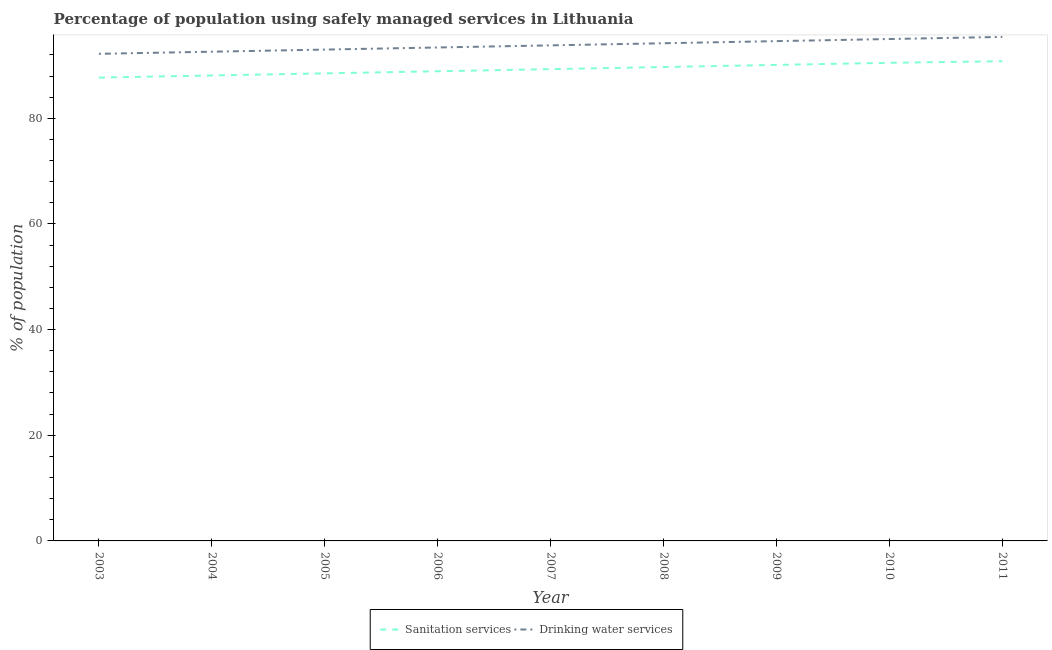What is the percentage of population who used drinking water services in 2003?
Your answer should be very brief. 92.2. Across all years, what is the maximum percentage of population who used drinking water services?
Provide a succinct answer. 95.4. Across all years, what is the minimum percentage of population who used drinking water services?
Ensure brevity in your answer.  92.2. In which year was the percentage of population who used sanitation services minimum?
Offer a terse response. 2003. What is the total percentage of population who used drinking water services in the graph?
Make the answer very short. 844.2. What is the difference between the percentage of population who used drinking water services in 2006 and that in 2009?
Offer a very short reply. -1.2. What is the difference between the percentage of population who used drinking water services in 2004 and the percentage of population who used sanitation services in 2006?
Provide a short and direct response. 3.7. What is the average percentage of population who used drinking water services per year?
Give a very brief answer. 93.8. In the year 2005, what is the difference between the percentage of population who used drinking water services and percentage of population who used sanitation services?
Your response must be concise. 4.5. In how many years, is the percentage of population who used drinking water services greater than 64 %?
Provide a succinct answer. 9. What is the ratio of the percentage of population who used drinking water services in 2005 to that in 2006?
Your response must be concise. 1. What is the difference between the highest and the second highest percentage of population who used drinking water services?
Make the answer very short. 0.4. What is the difference between the highest and the lowest percentage of population who used sanitation services?
Provide a succinct answer. 3.1. Does the percentage of population who used drinking water services monotonically increase over the years?
Offer a terse response. Yes. Is the percentage of population who used drinking water services strictly greater than the percentage of population who used sanitation services over the years?
Keep it short and to the point. Yes. How many lines are there?
Provide a succinct answer. 2. How many years are there in the graph?
Make the answer very short. 9. What is the difference between two consecutive major ticks on the Y-axis?
Your response must be concise. 20. Are the values on the major ticks of Y-axis written in scientific E-notation?
Your response must be concise. No. Does the graph contain grids?
Offer a very short reply. No. What is the title of the graph?
Your answer should be very brief. Percentage of population using safely managed services in Lithuania. Does "constant 2005 US$" appear as one of the legend labels in the graph?
Keep it short and to the point. No. What is the label or title of the Y-axis?
Make the answer very short. % of population. What is the % of population of Sanitation services in 2003?
Keep it short and to the point. 87.7. What is the % of population in Drinking water services in 2003?
Ensure brevity in your answer.  92.2. What is the % of population of Sanitation services in 2004?
Provide a short and direct response. 88.1. What is the % of population in Drinking water services in 2004?
Offer a very short reply. 92.6. What is the % of population in Sanitation services in 2005?
Your response must be concise. 88.5. What is the % of population of Drinking water services in 2005?
Your answer should be compact. 93. What is the % of population of Sanitation services in 2006?
Your response must be concise. 88.9. What is the % of population in Drinking water services in 2006?
Make the answer very short. 93.4. What is the % of population in Sanitation services in 2007?
Keep it short and to the point. 89.3. What is the % of population in Drinking water services in 2007?
Keep it short and to the point. 93.8. What is the % of population in Sanitation services in 2008?
Keep it short and to the point. 89.7. What is the % of population of Drinking water services in 2008?
Make the answer very short. 94.2. What is the % of population of Sanitation services in 2009?
Ensure brevity in your answer.  90.1. What is the % of population of Drinking water services in 2009?
Keep it short and to the point. 94.6. What is the % of population in Sanitation services in 2010?
Offer a very short reply. 90.5. What is the % of population of Drinking water services in 2010?
Offer a terse response. 95. What is the % of population in Sanitation services in 2011?
Give a very brief answer. 90.8. What is the % of population in Drinking water services in 2011?
Your answer should be compact. 95.4. Across all years, what is the maximum % of population of Sanitation services?
Your response must be concise. 90.8. Across all years, what is the maximum % of population in Drinking water services?
Make the answer very short. 95.4. Across all years, what is the minimum % of population in Sanitation services?
Give a very brief answer. 87.7. Across all years, what is the minimum % of population of Drinking water services?
Give a very brief answer. 92.2. What is the total % of population of Sanitation services in the graph?
Ensure brevity in your answer.  803.6. What is the total % of population of Drinking water services in the graph?
Your answer should be very brief. 844.2. What is the difference between the % of population of Drinking water services in 2003 and that in 2004?
Provide a succinct answer. -0.4. What is the difference between the % of population in Sanitation services in 2003 and that in 2005?
Ensure brevity in your answer.  -0.8. What is the difference between the % of population of Sanitation services in 2003 and that in 2006?
Make the answer very short. -1.2. What is the difference between the % of population of Sanitation services in 2003 and that in 2007?
Keep it short and to the point. -1.6. What is the difference between the % of population in Drinking water services in 2003 and that in 2007?
Your answer should be very brief. -1.6. What is the difference between the % of population in Drinking water services in 2003 and that in 2008?
Give a very brief answer. -2. What is the difference between the % of population of Sanitation services in 2003 and that in 2009?
Give a very brief answer. -2.4. What is the difference between the % of population of Drinking water services in 2003 and that in 2010?
Keep it short and to the point. -2.8. What is the difference between the % of population of Sanitation services in 2003 and that in 2011?
Your answer should be very brief. -3.1. What is the difference between the % of population of Sanitation services in 2004 and that in 2005?
Offer a very short reply. -0.4. What is the difference between the % of population of Sanitation services in 2004 and that in 2006?
Your answer should be very brief. -0.8. What is the difference between the % of population in Sanitation services in 2004 and that in 2007?
Offer a terse response. -1.2. What is the difference between the % of population of Drinking water services in 2004 and that in 2008?
Offer a terse response. -1.6. What is the difference between the % of population in Sanitation services in 2004 and that in 2009?
Offer a terse response. -2. What is the difference between the % of population in Sanitation services in 2004 and that in 2010?
Provide a short and direct response. -2.4. What is the difference between the % of population in Sanitation services in 2005 and that in 2006?
Make the answer very short. -0.4. What is the difference between the % of population in Drinking water services in 2005 and that in 2006?
Your response must be concise. -0.4. What is the difference between the % of population of Sanitation services in 2005 and that in 2007?
Give a very brief answer. -0.8. What is the difference between the % of population of Drinking water services in 2005 and that in 2008?
Give a very brief answer. -1.2. What is the difference between the % of population in Drinking water services in 2005 and that in 2011?
Ensure brevity in your answer.  -2.4. What is the difference between the % of population of Sanitation services in 2006 and that in 2007?
Your response must be concise. -0.4. What is the difference between the % of population of Sanitation services in 2006 and that in 2008?
Provide a succinct answer. -0.8. What is the difference between the % of population in Drinking water services in 2006 and that in 2008?
Your response must be concise. -0.8. What is the difference between the % of population of Drinking water services in 2006 and that in 2009?
Ensure brevity in your answer.  -1.2. What is the difference between the % of population in Sanitation services in 2006 and that in 2011?
Your answer should be very brief. -1.9. What is the difference between the % of population in Drinking water services in 2006 and that in 2011?
Make the answer very short. -2. What is the difference between the % of population in Sanitation services in 2007 and that in 2009?
Offer a very short reply. -0.8. What is the difference between the % of population of Sanitation services in 2008 and that in 2009?
Keep it short and to the point. -0.4. What is the difference between the % of population of Sanitation services in 2008 and that in 2011?
Your answer should be compact. -1.1. What is the difference between the % of population in Sanitation services in 2009 and that in 2010?
Offer a terse response. -0.4. What is the difference between the % of population of Sanitation services in 2009 and that in 2011?
Offer a terse response. -0.7. What is the difference between the % of population in Sanitation services in 2003 and the % of population in Drinking water services in 2011?
Offer a very short reply. -7.7. What is the difference between the % of population of Sanitation services in 2004 and the % of population of Drinking water services in 2009?
Your answer should be very brief. -6.5. What is the difference between the % of population in Sanitation services in 2005 and the % of population in Drinking water services in 2010?
Provide a succinct answer. -6.5. What is the difference between the % of population of Sanitation services in 2005 and the % of population of Drinking water services in 2011?
Give a very brief answer. -6.9. What is the difference between the % of population of Sanitation services in 2007 and the % of population of Drinking water services in 2008?
Ensure brevity in your answer.  -4.9. What is the difference between the % of population of Sanitation services in 2007 and the % of population of Drinking water services in 2010?
Offer a very short reply. -5.7. What is the difference between the % of population in Sanitation services in 2007 and the % of population in Drinking water services in 2011?
Ensure brevity in your answer.  -6.1. What is the difference between the % of population in Sanitation services in 2008 and the % of population in Drinking water services in 2009?
Offer a terse response. -4.9. What is the difference between the % of population in Sanitation services in 2008 and the % of population in Drinking water services in 2011?
Provide a succinct answer. -5.7. What is the difference between the % of population in Sanitation services in 2009 and the % of population in Drinking water services in 2010?
Your answer should be compact. -4.9. What is the difference between the % of population of Sanitation services in 2010 and the % of population of Drinking water services in 2011?
Offer a very short reply. -4.9. What is the average % of population in Sanitation services per year?
Give a very brief answer. 89.29. What is the average % of population of Drinking water services per year?
Ensure brevity in your answer.  93.8. In the year 2003, what is the difference between the % of population of Sanitation services and % of population of Drinking water services?
Offer a very short reply. -4.5. In the year 2004, what is the difference between the % of population in Sanitation services and % of population in Drinking water services?
Make the answer very short. -4.5. In the year 2006, what is the difference between the % of population of Sanitation services and % of population of Drinking water services?
Your answer should be very brief. -4.5. In the year 2011, what is the difference between the % of population of Sanitation services and % of population of Drinking water services?
Offer a terse response. -4.6. What is the ratio of the % of population of Drinking water services in 2003 to that in 2005?
Ensure brevity in your answer.  0.99. What is the ratio of the % of population of Sanitation services in 2003 to that in 2006?
Your answer should be compact. 0.99. What is the ratio of the % of population of Drinking water services in 2003 to that in 2006?
Offer a terse response. 0.99. What is the ratio of the % of population in Sanitation services in 2003 to that in 2007?
Offer a very short reply. 0.98. What is the ratio of the % of population of Drinking water services in 2003 to that in 2007?
Your answer should be compact. 0.98. What is the ratio of the % of population of Sanitation services in 2003 to that in 2008?
Keep it short and to the point. 0.98. What is the ratio of the % of population in Drinking water services in 2003 to that in 2008?
Provide a succinct answer. 0.98. What is the ratio of the % of population in Sanitation services in 2003 to that in 2009?
Your response must be concise. 0.97. What is the ratio of the % of population in Drinking water services in 2003 to that in 2009?
Your answer should be compact. 0.97. What is the ratio of the % of population of Sanitation services in 2003 to that in 2010?
Your answer should be compact. 0.97. What is the ratio of the % of population of Drinking water services in 2003 to that in 2010?
Keep it short and to the point. 0.97. What is the ratio of the % of population in Sanitation services in 2003 to that in 2011?
Your answer should be very brief. 0.97. What is the ratio of the % of population in Drinking water services in 2003 to that in 2011?
Your answer should be compact. 0.97. What is the ratio of the % of population of Sanitation services in 2004 to that in 2005?
Your answer should be compact. 1. What is the ratio of the % of population in Sanitation services in 2004 to that in 2007?
Your answer should be compact. 0.99. What is the ratio of the % of population of Drinking water services in 2004 to that in 2007?
Make the answer very short. 0.99. What is the ratio of the % of population in Sanitation services in 2004 to that in 2008?
Ensure brevity in your answer.  0.98. What is the ratio of the % of population of Sanitation services in 2004 to that in 2009?
Keep it short and to the point. 0.98. What is the ratio of the % of population in Drinking water services in 2004 to that in 2009?
Your answer should be compact. 0.98. What is the ratio of the % of population in Sanitation services in 2004 to that in 2010?
Keep it short and to the point. 0.97. What is the ratio of the % of population of Drinking water services in 2004 to that in 2010?
Give a very brief answer. 0.97. What is the ratio of the % of population of Sanitation services in 2004 to that in 2011?
Your answer should be very brief. 0.97. What is the ratio of the % of population in Drinking water services in 2004 to that in 2011?
Ensure brevity in your answer.  0.97. What is the ratio of the % of population in Sanitation services in 2005 to that in 2006?
Make the answer very short. 1. What is the ratio of the % of population of Sanitation services in 2005 to that in 2008?
Make the answer very short. 0.99. What is the ratio of the % of population of Drinking water services in 2005 to that in 2008?
Provide a succinct answer. 0.99. What is the ratio of the % of population of Sanitation services in 2005 to that in 2009?
Make the answer very short. 0.98. What is the ratio of the % of population in Drinking water services in 2005 to that in 2009?
Give a very brief answer. 0.98. What is the ratio of the % of population in Sanitation services in 2005 to that in 2010?
Ensure brevity in your answer.  0.98. What is the ratio of the % of population in Drinking water services in 2005 to that in 2010?
Give a very brief answer. 0.98. What is the ratio of the % of population in Sanitation services in 2005 to that in 2011?
Offer a very short reply. 0.97. What is the ratio of the % of population of Drinking water services in 2005 to that in 2011?
Your answer should be compact. 0.97. What is the ratio of the % of population of Sanitation services in 2006 to that in 2009?
Make the answer very short. 0.99. What is the ratio of the % of population of Drinking water services in 2006 to that in 2009?
Provide a succinct answer. 0.99. What is the ratio of the % of population of Sanitation services in 2006 to that in 2010?
Give a very brief answer. 0.98. What is the ratio of the % of population of Drinking water services in 2006 to that in 2010?
Make the answer very short. 0.98. What is the ratio of the % of population in Sanitation services in 2006 to that in 2011?
Give a very brief answer. 0.98. What is the ratio of the % of population in Drinking water services in 2007 to that in 2008?
Your answer should be compact. 1. What is the ratio of the % of population of Sanitation services in 2007 to that in 2009?
Make the answer very short. 0.99. What is the ratio of the % of population of Sanitation services in 2007 to that in 2010?
Provide a short and direct response. 0.99. What is the ratio of the % of population in Drinking water services in 2007 to that in 2010?
Provide a short and direct response. 0.99. What is the ratio of the % of population in Sanitation services in 2007 to that in 2011?
Offer a very short reply. 0.98. What is the ratio of the % of population in Drinking water services in 2007 to that in 2011?
Give a very brief answer. 0.98. What is the ratio of the % of population in Drinking water services in 2008 to that in 2009?
Provide a succinct answer. 1. What is the ratio of the % of population of Drinking water services in 2008 to that in 2010?
Make the answer very short. 0.99. What is the ratio of the % of population in Sanitation services in 2008 to that in 2011?
Ensure brevity in your answer.  0.99. What is the ratio of the % of population in Drinking water services in 2008 to that in 2011?
Your answer should be compact. 0.99. What is the ratio of the % of population of Drinking water services in 2009 to that in 2010?
Offer a terse response. 1. What is the difference between the highest and the lowest % of population in Sanitation services?
Your answer should be very brief. 3.1. What is the difference between the highest and the lowest % of population of Drinking water services?
Offer a very short reply. 3.2. 